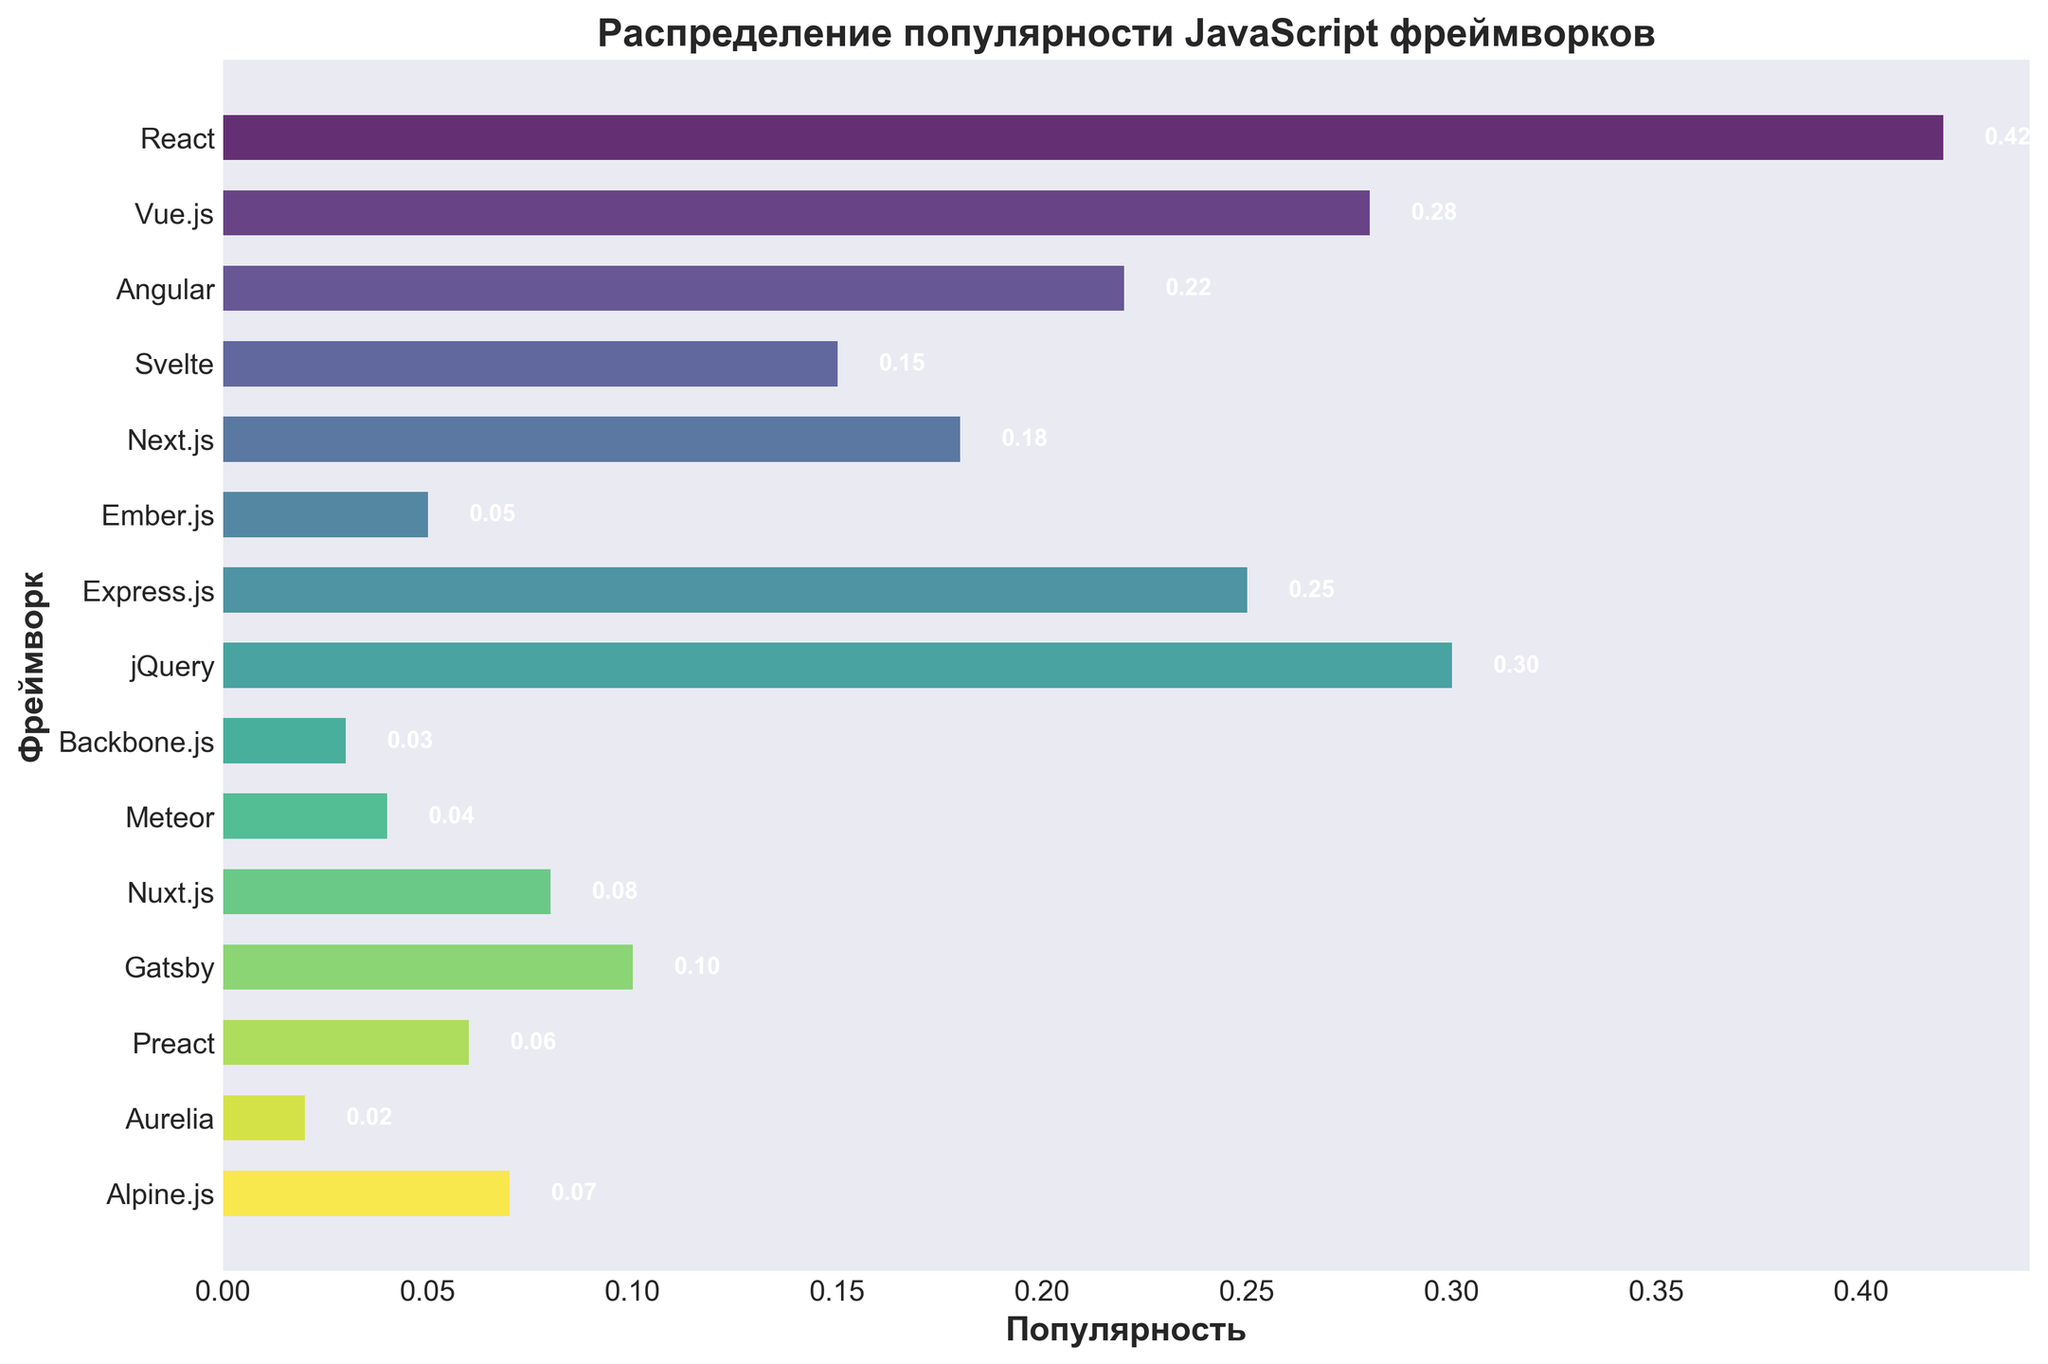What is the most popular JavaScript framework according to the plot? The most popular JavaScript framework can be identified by looking at the bar with the highest value on the horizontal axis.
Answer: React How many frameworks have a popularity less than 0.10? Count the number of bars that have a value less than 0.10 on the horizontal axis.
Answer: 5 Which framework has a slightly higher popularity than 0.25? Find the framework with a value just above 0.25 by looking at the horizontal bars.
Answer: jQuery What is the sum of popularity for Angular, Vue.js, and Svelte? Add the popularity values for Angular (0.22), Vue.js (0.28), and Svelte (0.15): 0.22 + 0.28 + 0.15.
Answer: 0.65 Which framework is more popular, Express.js or Next.js, and by how much? Compare the popularity values of Express.js (0.25) and Next.js (0.18), then subtract the smaller value from the larger one: 0.25 - 0.18.
Answer: Express.js by 0.07 What is the least popular framework? Identify the framework with the smallest value on the horizontal axis.
Answer: Aurelia Which frameworks have a popularity greater than 0.20? List the frameworks with values exceeding 0.20 according to the horizontal bars.
Answer: React, Vue.js, Angular, jQuery What is the median popularity value of the frameworks? Arrange the popularity values in ascending order and find the middle value. If there is an even number of values, average the two middle ones. The ordered values are: [0.02, 0.03, 0.04, 0.05, 0.06, 0.07, 0.08, 0.10, 0.15, 0.18, 0.22, 0.25, 0.28, 0.30, 0.42]. The median value is the 8th value in this list.
Answer: 0.10 How much more popular is React compared to Backbone.js? Subtract Backbone.js's popularity (0.03) from React's popularity (0.42): 0.42 - 0.03.
Answer: 0.39 What is the combined popularity of frameworks with a value greater than or equal to 0.25? Add the popularity values for React (0.42), Vue.js (0.28), Express.js (0.25), and jQuery (0.30): 0.42 + 0.28 + 0.25 + 0.30.
Answer: 1.25 